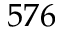Convert formula to latex. <formula><loc_0><loc_0><loc_500><loc_500>5 7 6</formula> 